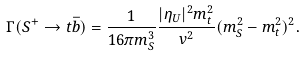Convert formula to latex. <formula><loc_0><loc_0><loc_500><loc_500>\Gamma ( S ^ { + } \to t \bar { b } ) = \frac { 1 } { 1 6 \pi m _ { S } ^ { 3 } } \frac { | \eta _ { U } | ^ { 2 } m _ { t } ^ { 2 } } { v ^ { 2 } } ( m _ { S } ^ { 2 } - m _ { t } ^ { 2 } ) ^ { 2 } .</formula> 